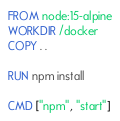<code> <loc_0><loc_0><loc_500><loc_500><_Dockerfile_>FROM node:15-alpine
WORKDIR /docker
COPY . .

RUN npm install

CMD ["npm", "start"]</code> 